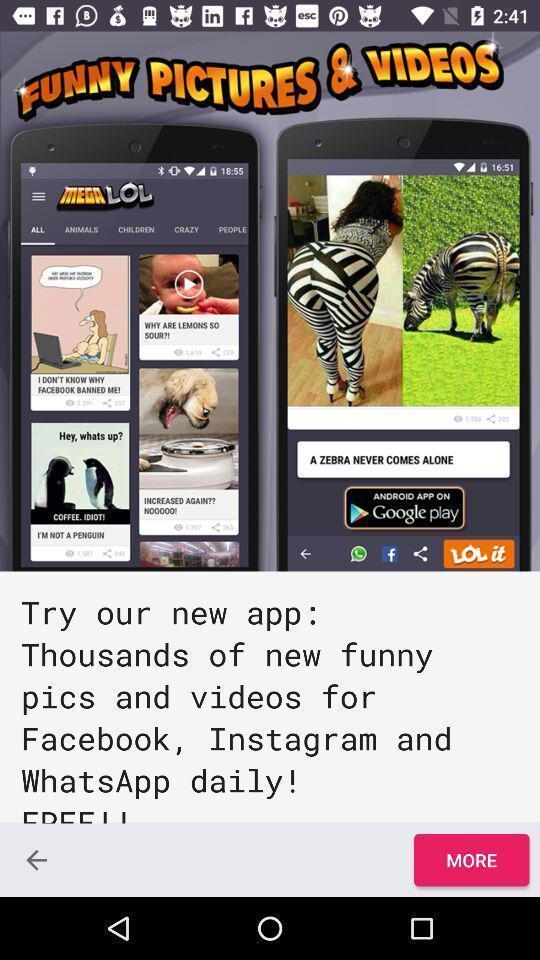Give me a summary of this screen capture. Welcome page of a social app. 